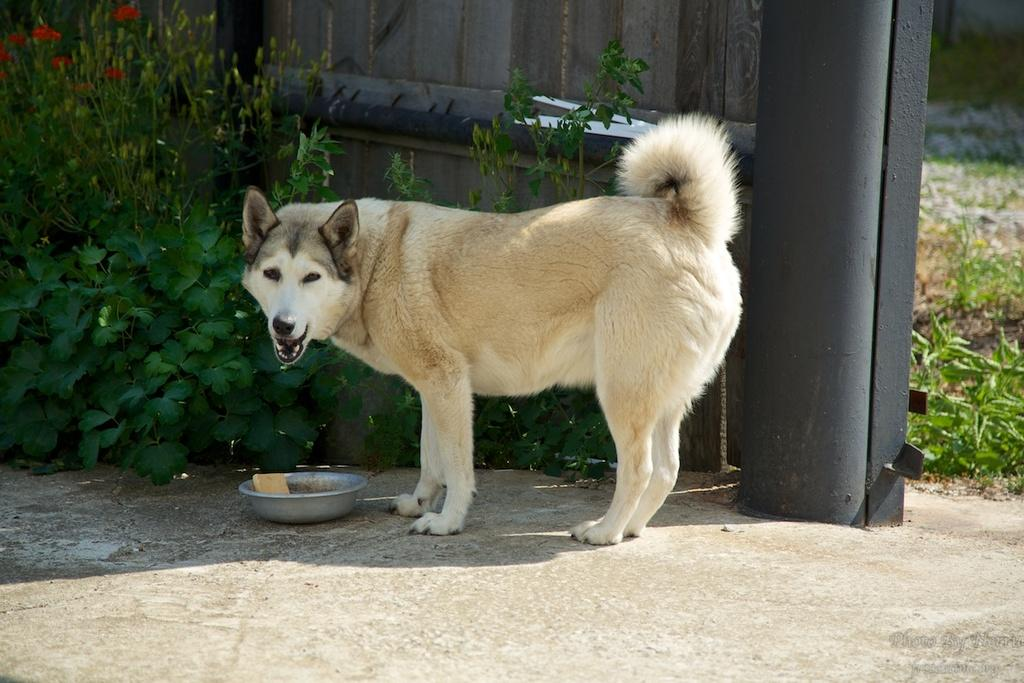What is the main subject in the center of the image? There is a dog in the center of the image. What can be seen in the background of the image? There is a fence and plants in the background of the image. What is located at the bottom of the image? There is a food bowl at the bottom of the image. What holiday is the dog celebrating in the image? There is no indication of a holiday in the image. Who is the manager of the dog in the image? There is no indication of a manager or any human presence. 